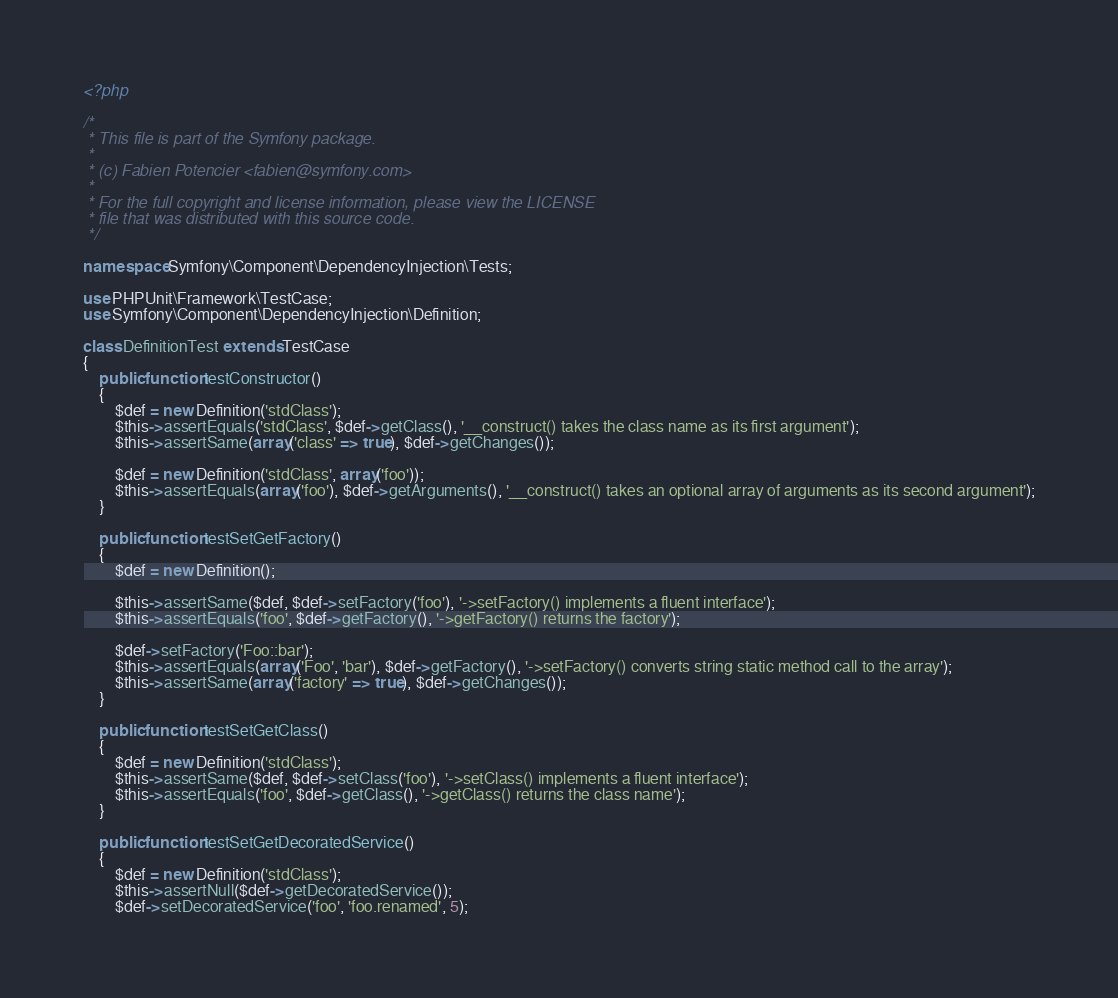Convert code to text. <code><loc_0><loc_0><loc_500><loc_500><_PHP_><?php

/*
 * This file is part of the Symfony package.
 *
 * (c) Fabien Potencier <fabien@symfony.com>
 *
 * For the full copyright and license information, please view the LICENSE
 * file that was distributed with this source code.
 */

namespace Symfony\Component\DependencyInjection\Tests;

use PHPUnit\Framework\TestCase;
use Symfony\Component\DependencyInjection\Definition;

class DefinitionTest extends TestCase
{
    public function testConstructor()
    {
        $def = new Definition('stdClass');
        $this->assertEquals('stdClass', $def->getClass(), '__construct() takes the class name as its first argument');
        $this->assertSame(array('class' => true), $def->getChanges());

        $def = new Definition('stdClass', array('foo'));
        $this->assertEquals(array('foo'), $def->getArguments(), '__construct() takes an optional array of arguments as its second argument');
    }

    public function testSetGetFactory()
    {
        $def = new Definition();

        $this->assertSame($def, $def->setFactory('foo'), '->setFactory() implements a fluent interface');
        $this->assertEquals('foo', $def->getFactory(), '->getFactory() returns the factory');

        $def->setFactory('Foo::bar');
        $this->assertEquals(array('Foo', 'bar'), $def->getFactory(), '->setFactory() converts string static method call to the array');
        $this->assertSame(array('factory' => true), $def->getChanges());
    }

    public function testSetGetClass()
    {
        $def = new Definition('stdClass');
        $this->assertSame($def, $def->setClass('foo'), '->setClass() implements a fluent interface');
        $this->assertEquals('foo', $def->getClass(), '->getClass() returns the class name');
    }

    public function testSetGetDecoratedService()
    {
        $def = new Definition('stdClass');
        $this->assertNull($def->getDecoratedService());
        $def->setDecoratedService('foo', 'foo.renamed', 5);</code> 